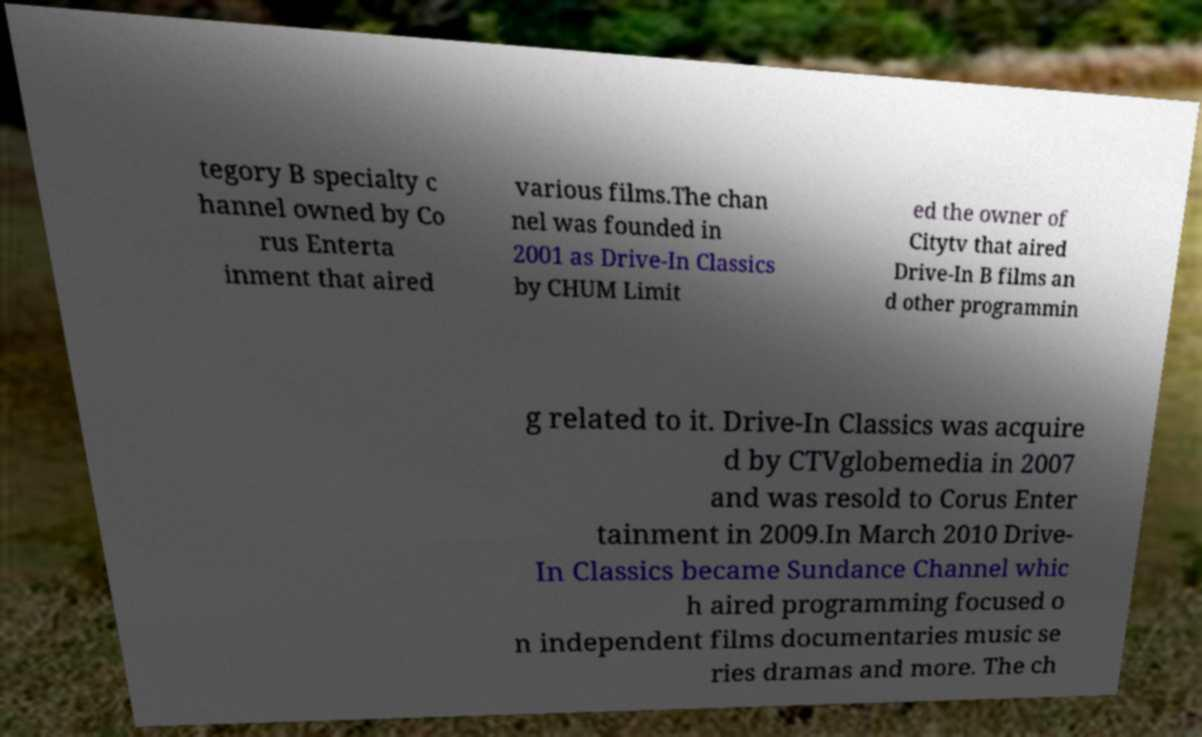There's text embedded in this image that I need extracted. Can you transcribe it verbatim? tegory B specialty c hannel owned by Co rus Enterta inment that aired various films.The chan nel was founded in 2001 as Drive-In Classics by CHUM Limit ed the owner of Citytv that aired Drive-In B films an d other programmin g related to it. Drive-In Classics was acquire d by CTVglobemedia in 2007 and was resold to Corus Enter tainment in 2009.In March 2010 Drive- In Classics became Sundance Channel whic h aired programming focused o n independent films documentaries music se ries dramas and more. The ch 